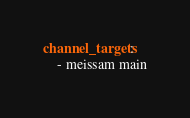<code> <loc_0><loc_0><loc_500><loc_500><_YAML_>channel_targets:
    - meissam main
</code> 